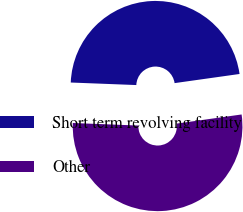Convert chart to OTSL. <chart><loc_0><loc_0><loc_500><loc_500><pie_chart><fcel>Short term revolving facility<fcel>Other<nl><fcel>47.16%<fcel>52.84%<nl></chart> 